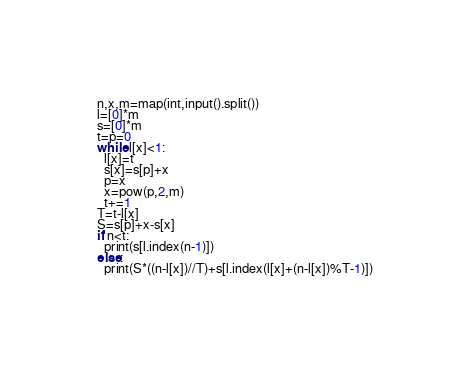Convert code to text. <code><loc_0><loc_0><loc_500><loc_500><_Python_>n,x,m=map(int,input().split())
l=[0]*m
s=[0]*m
t=p=0
while l[x]<1:
  l[x]=t
  s[x]=s[p]+x
  p=x
  x=pow(p,2,m)
  t+=1
T=t-l[x]
S=s[p]+x-s[x]
if n<t:
  print(s[l.index(n-1)])
else:
  print(S*((n-l[x])//T)+s[l.index(l[x]+(n-l[x])%T-1)])</code> 